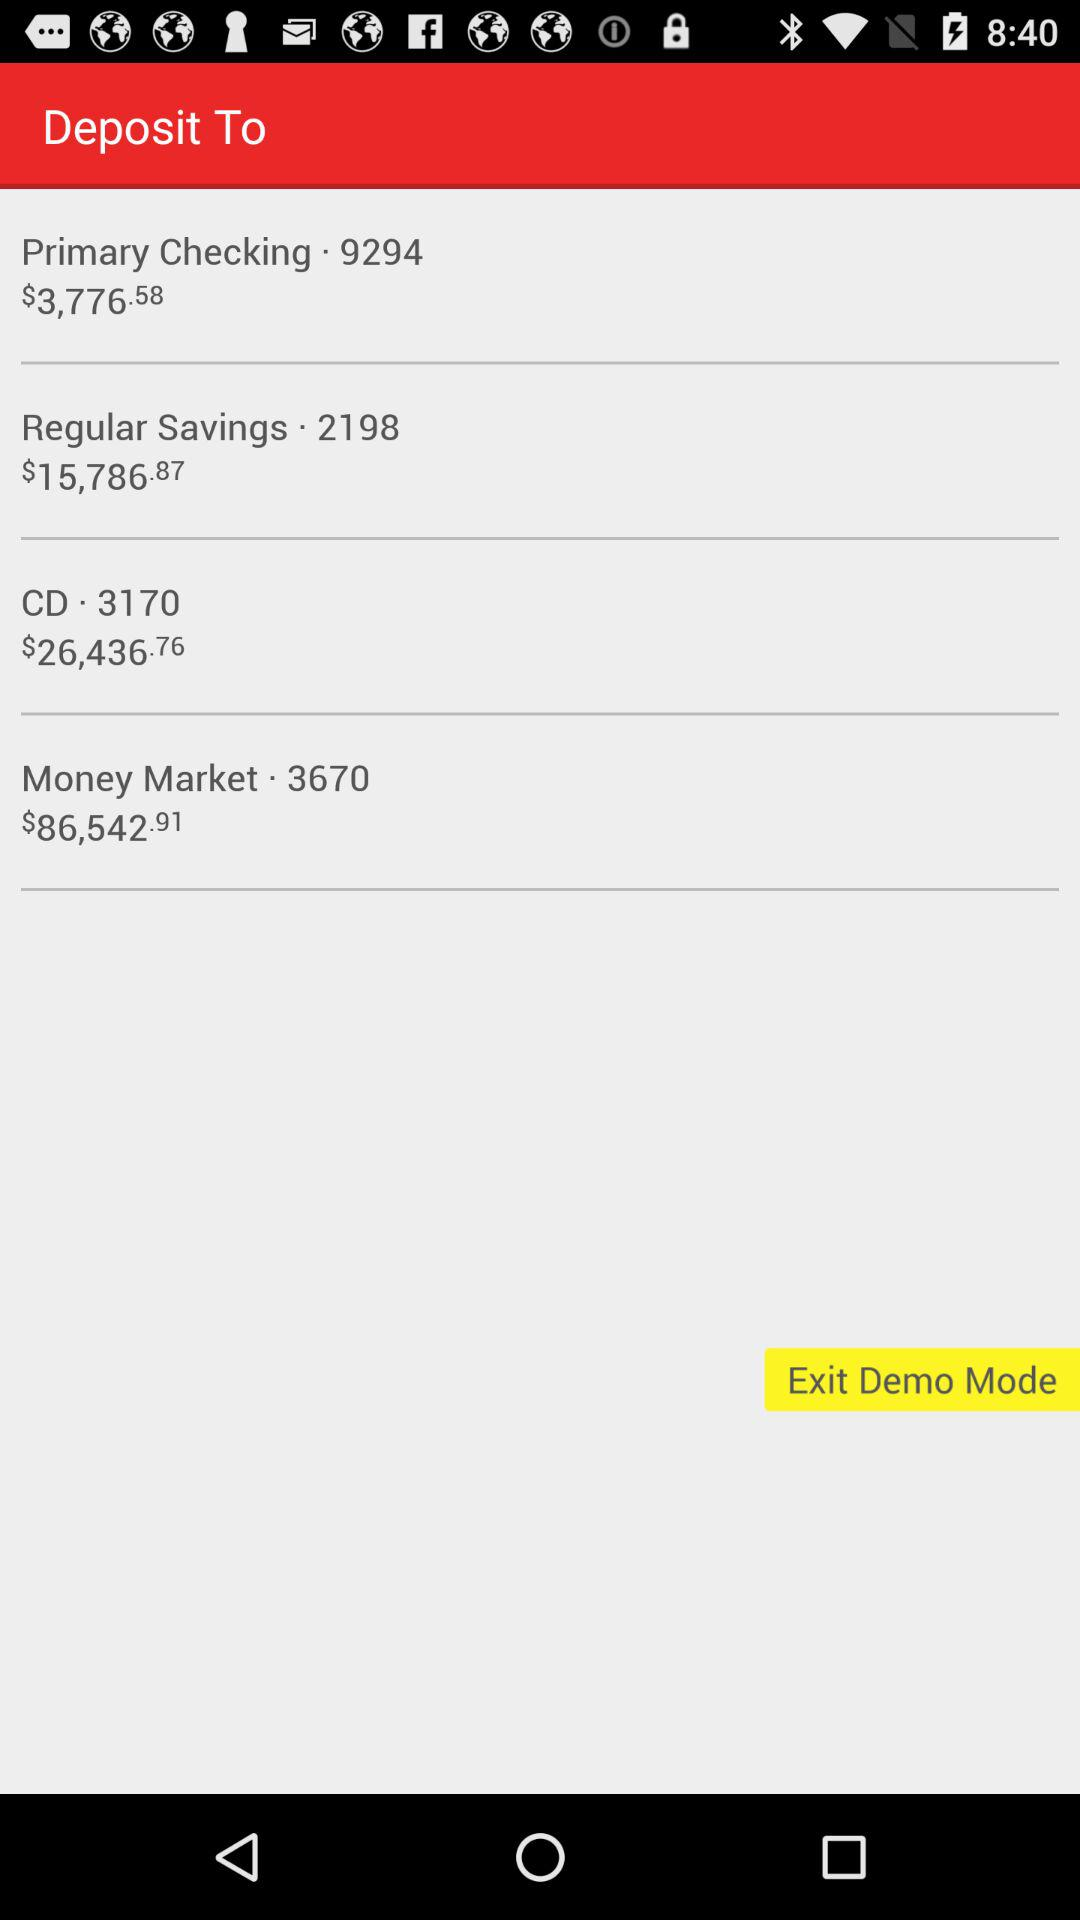What is the number mentioned beside "Primary Checking"? The number mentioned beside "Primary Checking" is 9294. 